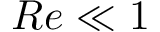<formula> <loc_0><loc_0><loc_500><loc_500>R e \ll 1</formula> 